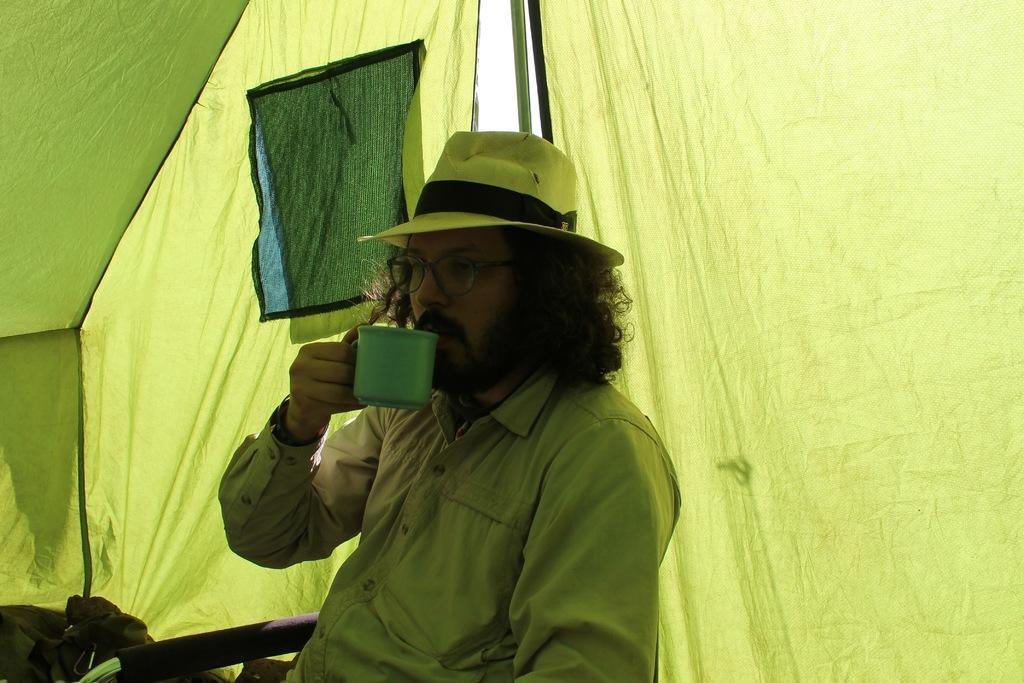In one or two sentences, can you explain what this image depicts? In this image we can see a man sitting on the chair and holding a cup in his hand. In the background we can see tent. 